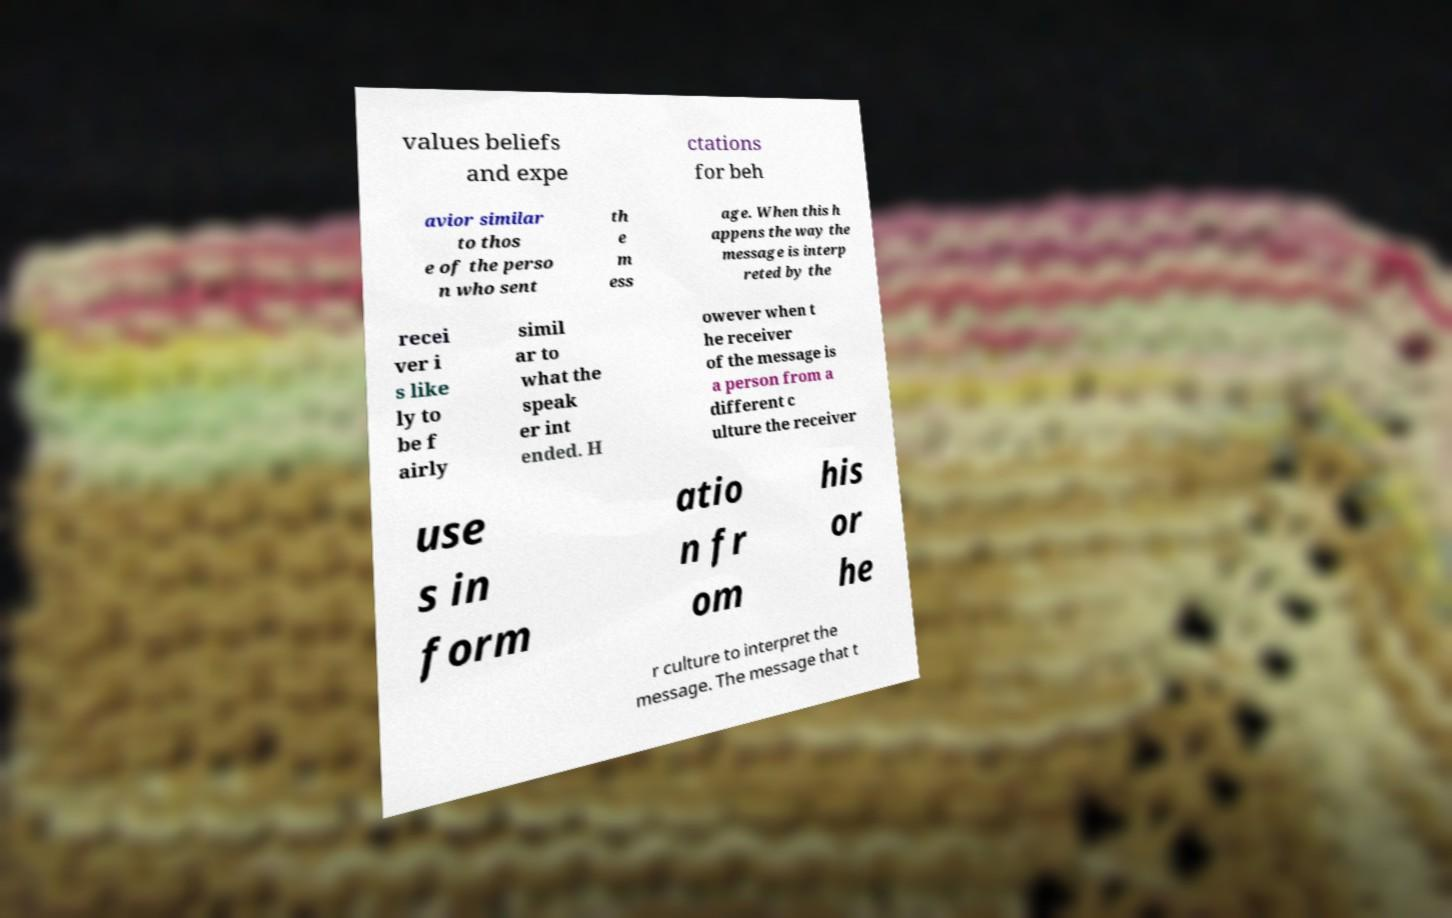Can you read and provide the text displayed in the image?This photo seems to have some interesting text. Can you extract and type it out for me? values beliefs and expe ctations for beh avior similar to thos e of the perso n who sent th e m ess age. When this h appens the way the message is interp reted by the recei ver i s like ly to be f airly simil ar to what the speak er int ended. H owever when t he receiver of the message is a person from a different c ulture the receiver use s in form atio n fr om his or he r culture to interpret the message. The message that t 